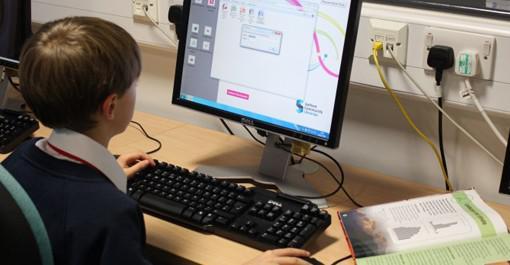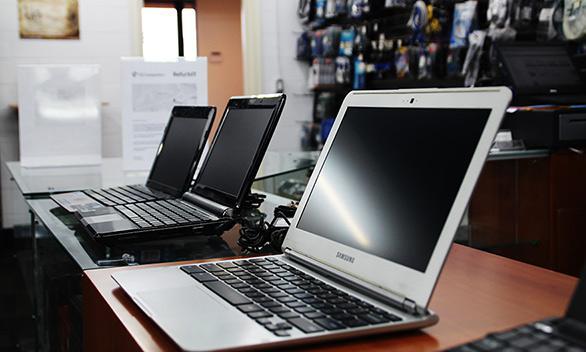The first image is the image on the left, the second image is the image on the right. Assess this claim about the two images: "Human hands are near a keyboard in one image.". Correct or not? Answer yes or no. Yes. The first image is the image on the left, the second image is the image on the right. Considering the images on both sides, is "There is at least one human hand that is at least partially visible" valid? Answer yes or no. Yes. 